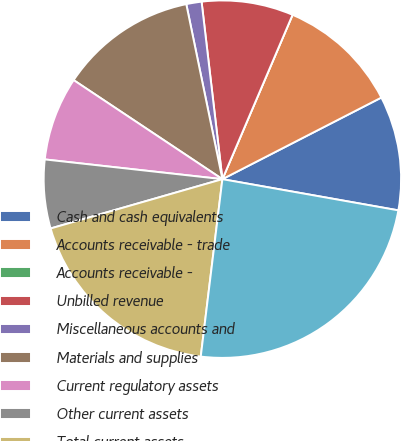Convert chart to OTSL. <chart><loc_0><loc_0><loc_500><loc_500><pie_chart><fcel>Cash and cash equivalents<fcel>Accounts receivable - trade<fcel>Accounts receivable -<fcel>Unbilled revenue<fcel>Miscellaneous accounts and<fcel>Materials and supplies<fcel>Current regulatory assets<fcel>Other current assets<fcel>Total current assets<fcel>Property and Plant Net<nl><fcel>10.34%<fcel>11.03%<fcel>0.0%<fcel>8.28%<fcel>1.38%<fcel>12.41%<fcel>7.59%<fcel>6.21%<fcel>18.62%<fcel>24.14%<nl></chart> 